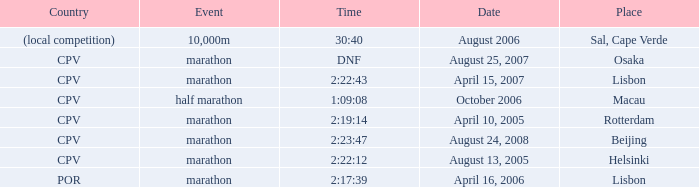In which country does the 10,000m event take place? (local competition). 